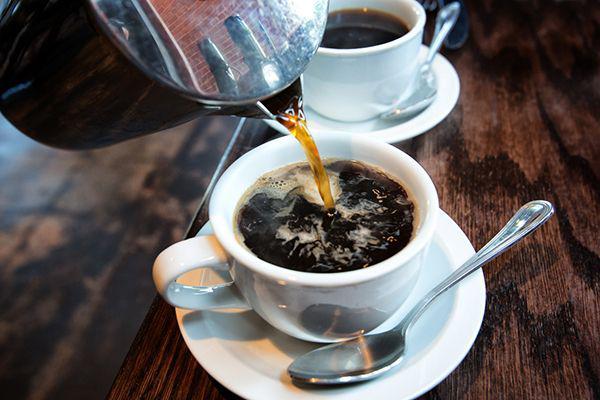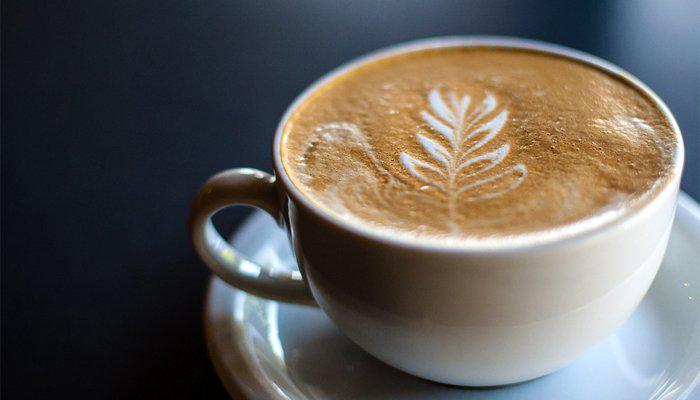The first image is the image on the left, the second image is the image on the right. For the images displayed, is the sentence "There are no more than two cups of coffee." factually correct? Answer yes or no. No. 